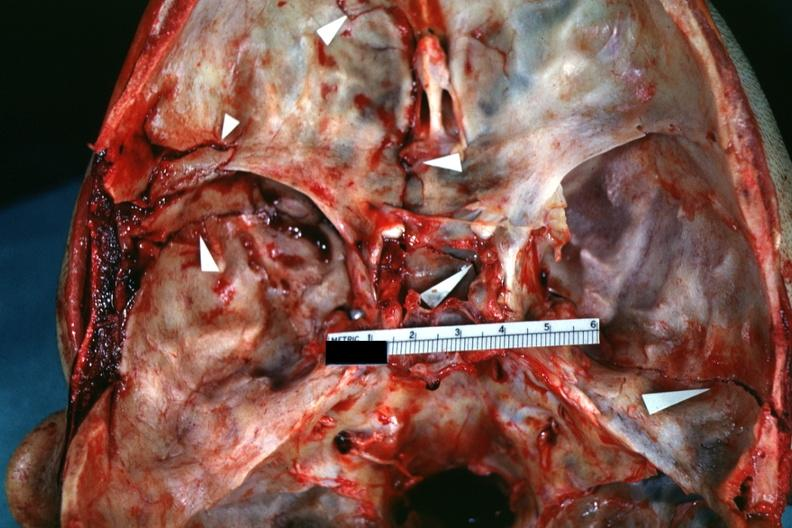what does this image show?
Answer the question using a single word or phrase. Close-up view of lesions slide which is brain from case 